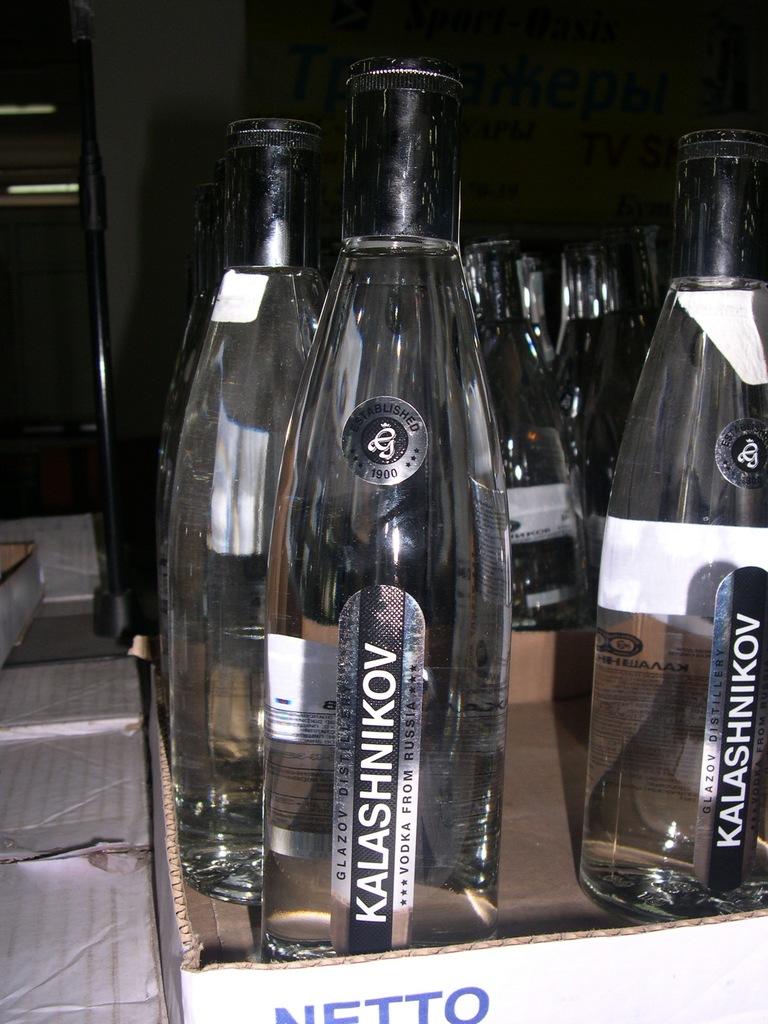What is the brand of the drink?
Your answer should be very brief. Kalashnikov. Where is the vodka from?
Your answer should be compact. Russia. 